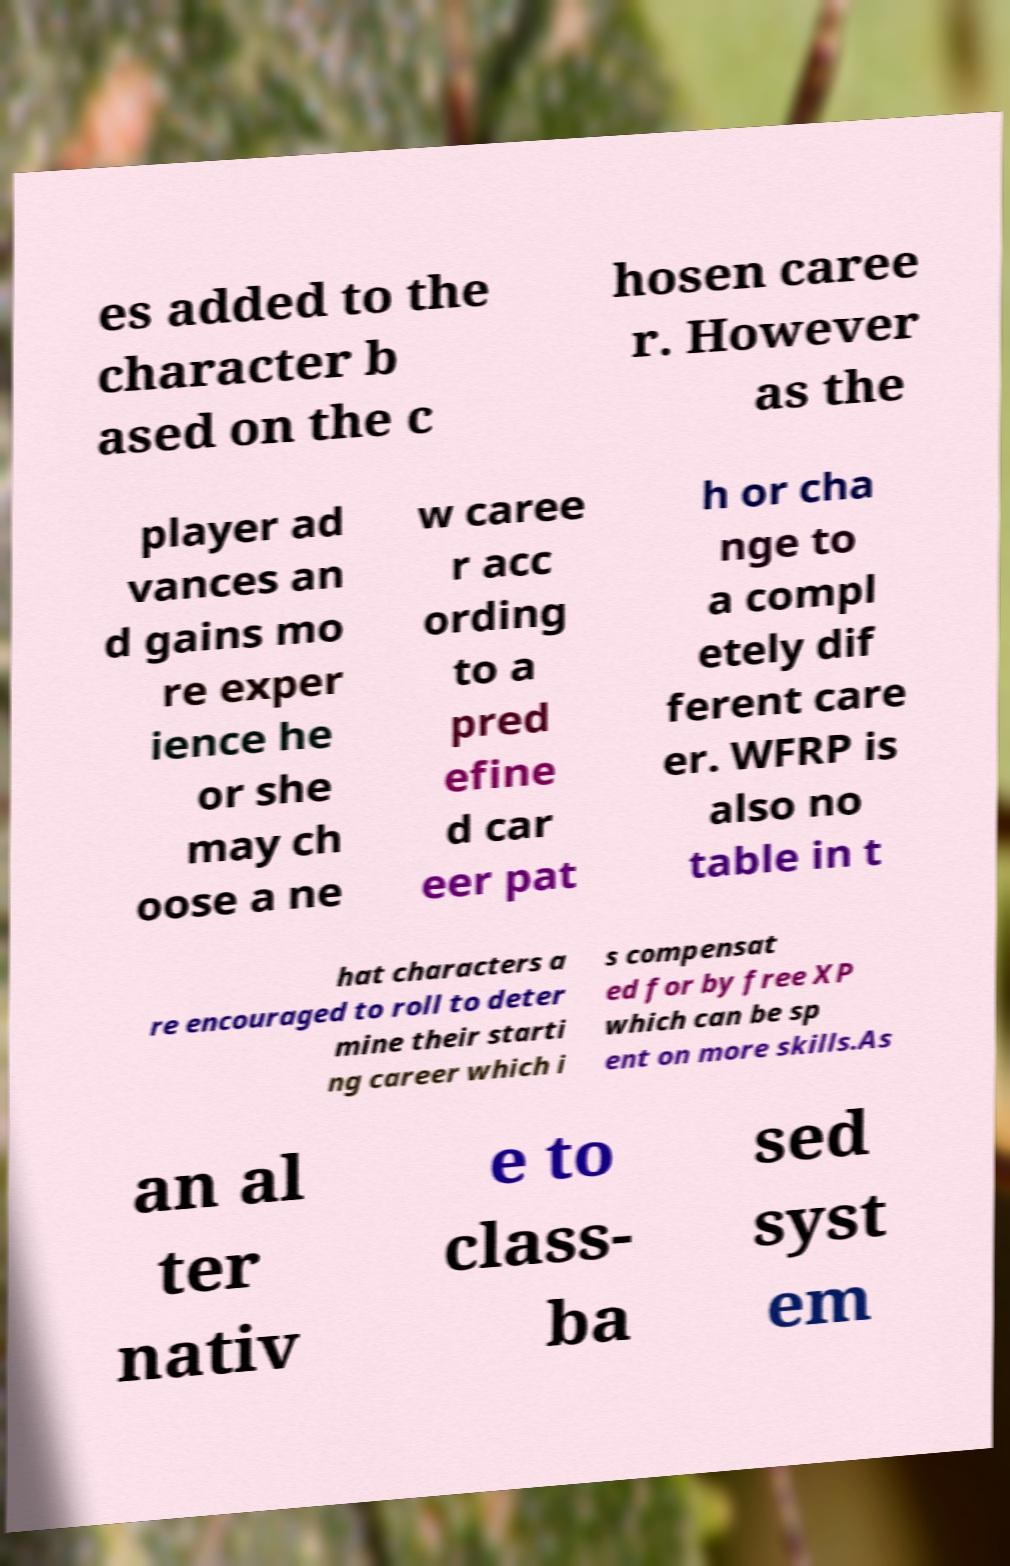Could you assist in decoding the text presented in this image and type it out clearly? es added to the character b ased on the c hosen caree r. However as the player ad vances an d gains mo re exper ience he or she may ch oose a ne w caree r acc ording to a pred efine d car eer pat h or cha nge to a compl etely dif ferent care er. WFRP is also no table in t hat characters a re encouraged to roll to deter mine their starti ng career which i s compensat ed for by free XP which can be sp ent on more skills.As an al ter nativ e to class- ba sed syst em 